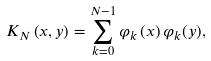<formula> <loc_0><loc_0><loc_500><loc_500>K _ { N } \left ( x , y \right ) = \sum _ { k = 0 } ^ { N - 1 } \varphi _ { k } \left ( x \right ) \varphi _ { k } ( y ) ,</formula> 